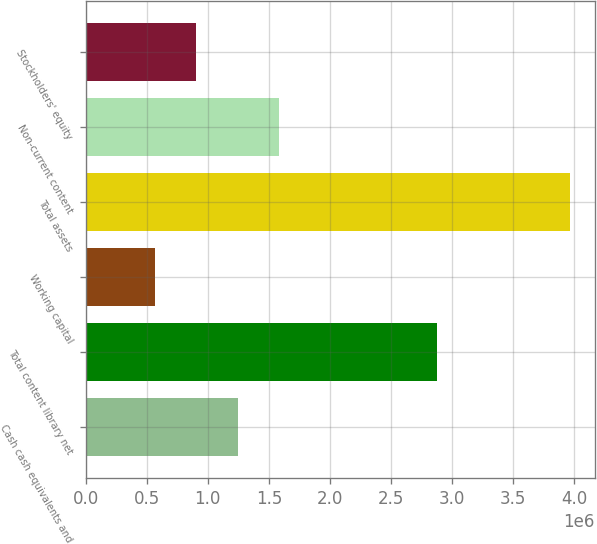<chart> <loc_0><loc_0><loc_500><loc_500><bar_chart><fcel>Cash cash equivalents and<fcel>Total content library net<fcel>Working capital<fcel>Total assets<fcel>Non-current content<fcel>Stockholders' equity<nl><fcel>1.24547e+06<fcel>2.87417e+06<fcel>564865<fcel>3.96789e+06<fcel>1.58577e+06<fcel>905168<nl></chart> 